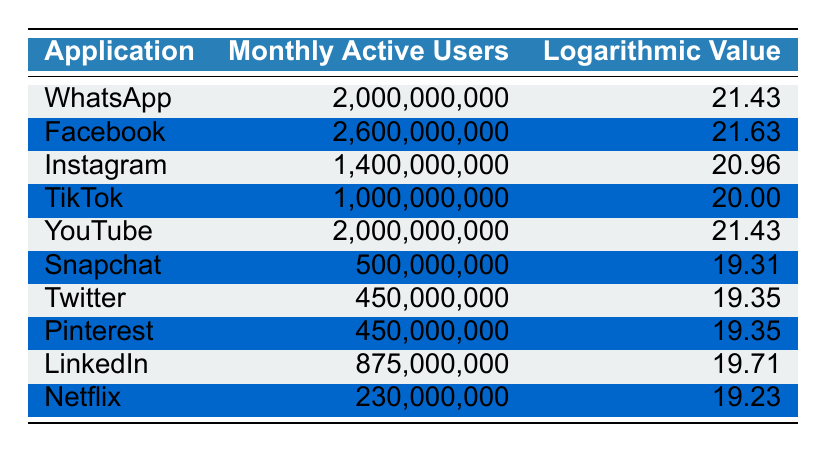What is the monthly active user count for TikTok? The value for TikTok's monthly active users is directly stated in the table. It shows TikTok has 1,000,000,000 monthly active users.
Answer: 1,000,000,000 Which application has the highest logarithmic value? By scanning the logarithmic values in the table, Facebook has the highest logarithmic value at 21.63.
Answer: Facebook What is the difference in monthly active users between Instagram and Snapchat? Instagram has 1,400,000,000 and Snapchat has 500,000,000 users. The difference is calculated as 1,400,000,000 - 500,000,000 = 900,000,000.
Answer: 900,000,000 Are there more monthly active users for LinkedIn than for Twitter? LinkedIn has 875,000,000 users and Twitter has 450,000,000 users. Since 875,000,000 is greater than 450,000,000, the answer is yes.
Answer: Yes What is the average monthly active user count for the top three applications? The top three applications by user count are Facebook (2,600,000,000), WhatsApp (2,000,000,000), and Instagram (1,400,000,000). The sum is 2,600,000,000 + 2,000,000,000 + 1,400,000,000 = 6,000,000,000. The average is 6,000,000,000 / 3 = 2,000,000,000.
Answer: 2,000,000,000 Which application has a logarithmic value closest to Snapchat? Snapchat's logarithmic value is 19.31. The closest logarithmic values in the table are Twitter and Pinterest, both with a value of 19.35.
Answer: Twitter and Pinterest 